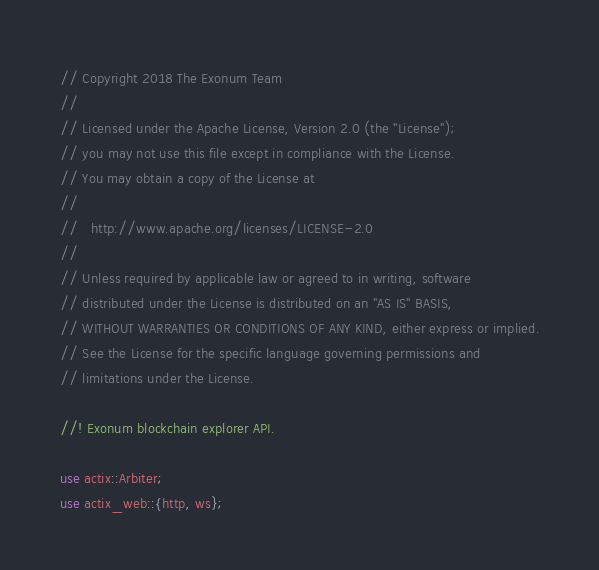<code> <loc_0><loc_0><loc_500><loc_500><_Rust_>// Copyright 2018 The Exonum Team
//
// Licensed under the Apache License, Version 2.0 (the "License");
// you may not use this file except in compliance with the License.
// You may obtain a copy of the License at
//
//   http://www.apache.org/licenses/LICENSE-2.0
//
// Unless required by applicable law or agreed to in writing, software
// distributed under the License is distributed on an "AS IS" BASIS,
// WITHOUT WARRANTIES OR CONDITIONS OF ANY KIND, either express or implied.
// See the License for the specific language governing permissions and
// limitations under the License.

//! Exonum blockchain explorer API.

use actix::Arbiter;
use actix_web::{http, ws};</code> 